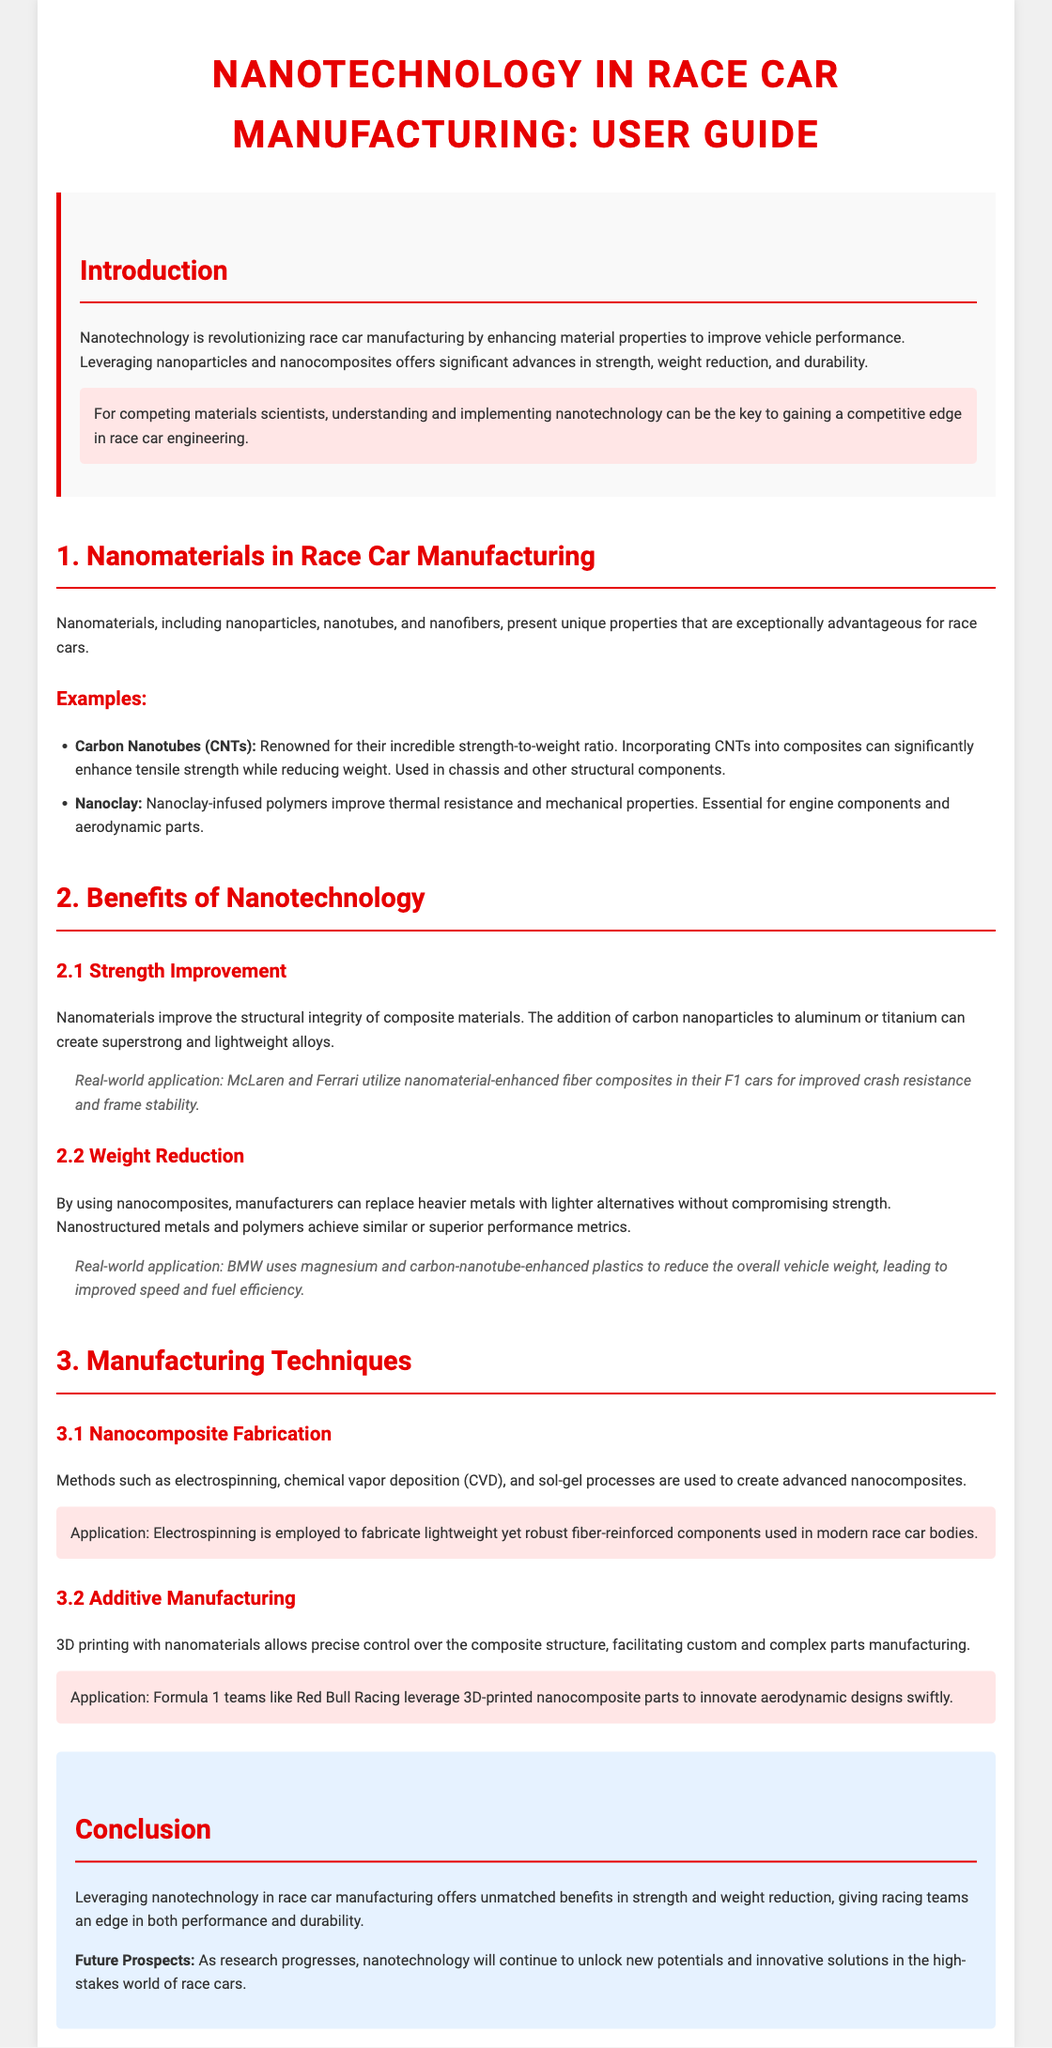What is the title of the user guide? The title is prominently displayed at the top of the document, indicating the focus on nanotechnology in race car manufacturing.
Answer: Nanotechnology in Race Car Manufacturing: User Guide What are carbon nanotubes known for? The document describes carbon nanotubes as having an incredible strength-to-weight ratio, making them advantageous in structural components.
Answer: Incredible strength-to-weight ratio Which two race teams use nanomaterial-enhanced composites? The user guide provides specific examples of race teams incorporating nanotechnology into their vehicles, highlighting their usage for performance gains.
Answer: McLaren and Ferrari What manufacturing technique is mentioned for creating nanocomposites? The document lists specific techniques and highlights electrospinning as a method for fabricating lightweight components.
Answer: Electrospinning What benefit does nanotechnology provide in terms of vehicle weight? The guide explains that nanotechnology allows for replacing heavier metals with lighter alternatives without compromising strength.
Answer: Weight reduction What type of manufacturing does Formula 1 teams like Red Bull Racing utilize? The document refers to a specific modern manufacturing approach that allows for innovation in aerodynamic designs.
Answer: 3D-printed nanocomposite parts How does the user guide conclude about the future of nanotechnology in racing? The conclusion section summarizes the potential and innovative solutions that ongoing research in nanotechnology will continue to provide in race car manufacturing.
Answer: Unlock new potentials What are the key properties mentioned regarding nanomaterials? The document specifies unique advantages of nanomaterials, emphasizing improvements in strength, weight reduction, and durability.
Answer: Strength, weight reduction, durability What example is given for nanoclay use? The guide lists a specific application of nanoclay in enhancing properties of specific automotive components.
Answer: Engine components and aerodynamic parts 